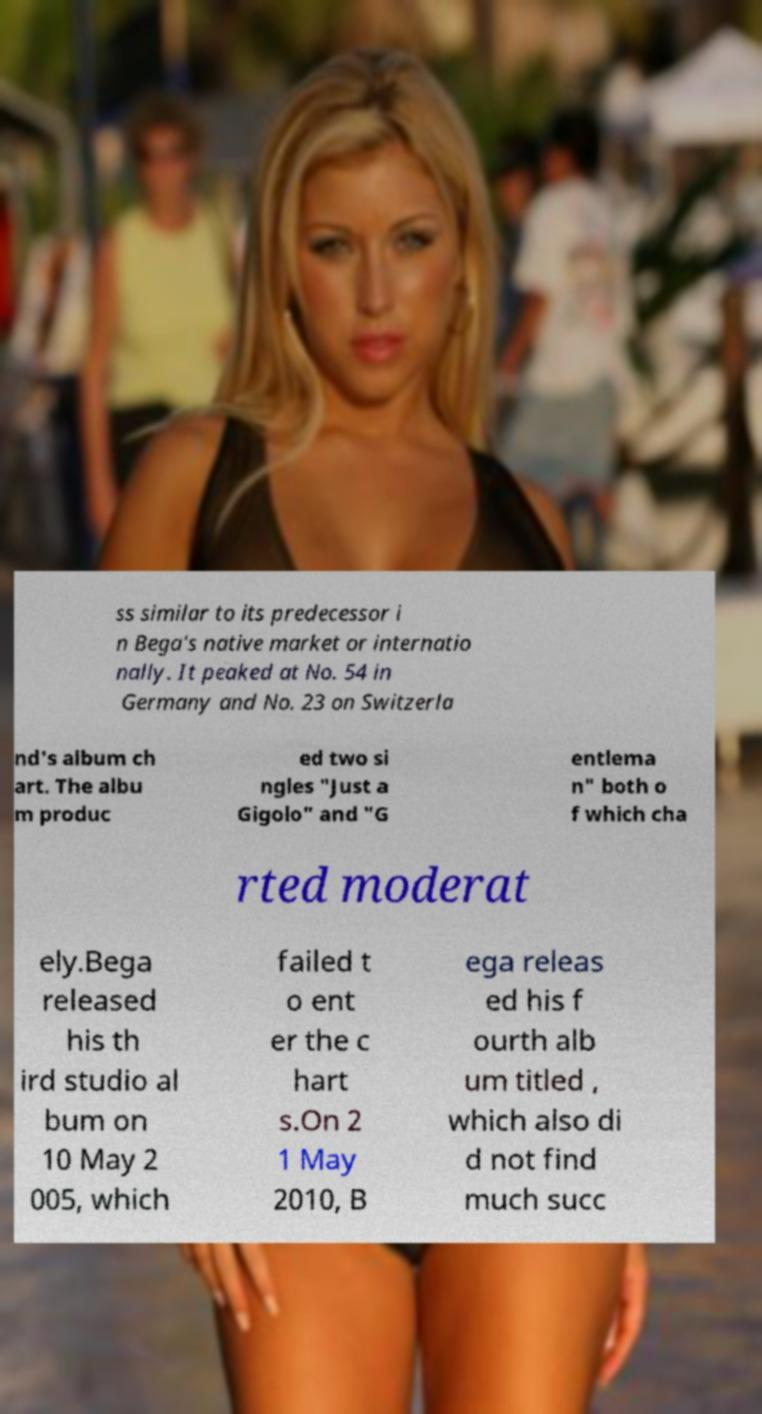Please identify and transcribe the text found in this image. ss similar to its predecessor i n Bega's native market or internatio nally. It peaked at No. 54 in Germany and No. 23 on Switzerla nd's album ch art. The albu m produc ed two si ngles "Just a Gigolo" and "G entlema n" both o f which cha rted moderat ely.Bega released his th ird studio al bum on 10 May 2 005, which failed t o ent er the c hart s.On 2 1 May 2010, B ega releas ed his f ourth alb um titled , which also di d not find much succ 